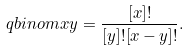Convert formula to latex. <formula><loc_0><loc_0><loc_500><loc_500>\ q b i n o m { x } { y } = \frac { [ x ] ! } { [ y ] ! [ x - y ] ! } .</formula> 